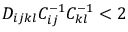Convert formula to latex. <formula><loc_0><loc_0><loc_500><loc_500>D _ { i j k l } C _ { i j } ^ { - 1 } C _ { k l } ^ { - 1 } < 2</formula> 